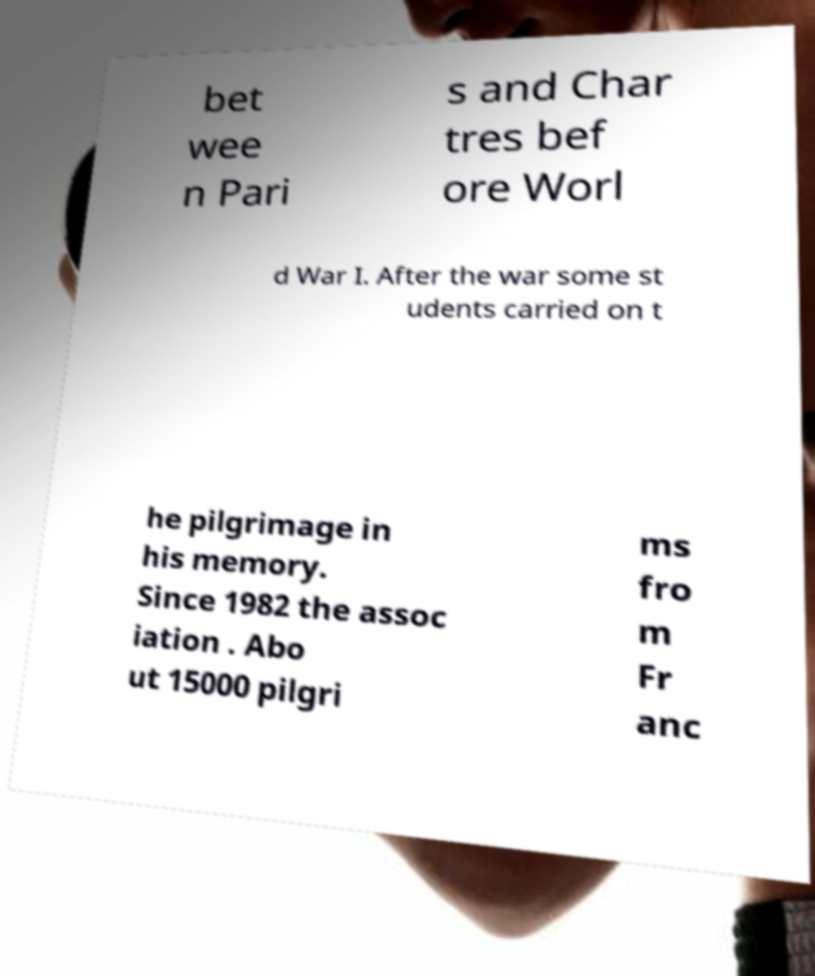I need the written content from this picture converted into text. Can you do that? bet wee n Pari s and Char tres bef ore Worl d War I. After the war some st udents carried on t he pilgrimage in his memory. Since 1982 the assoc iation . Abo ut 15000 pilgri ms fro m Fr anc 